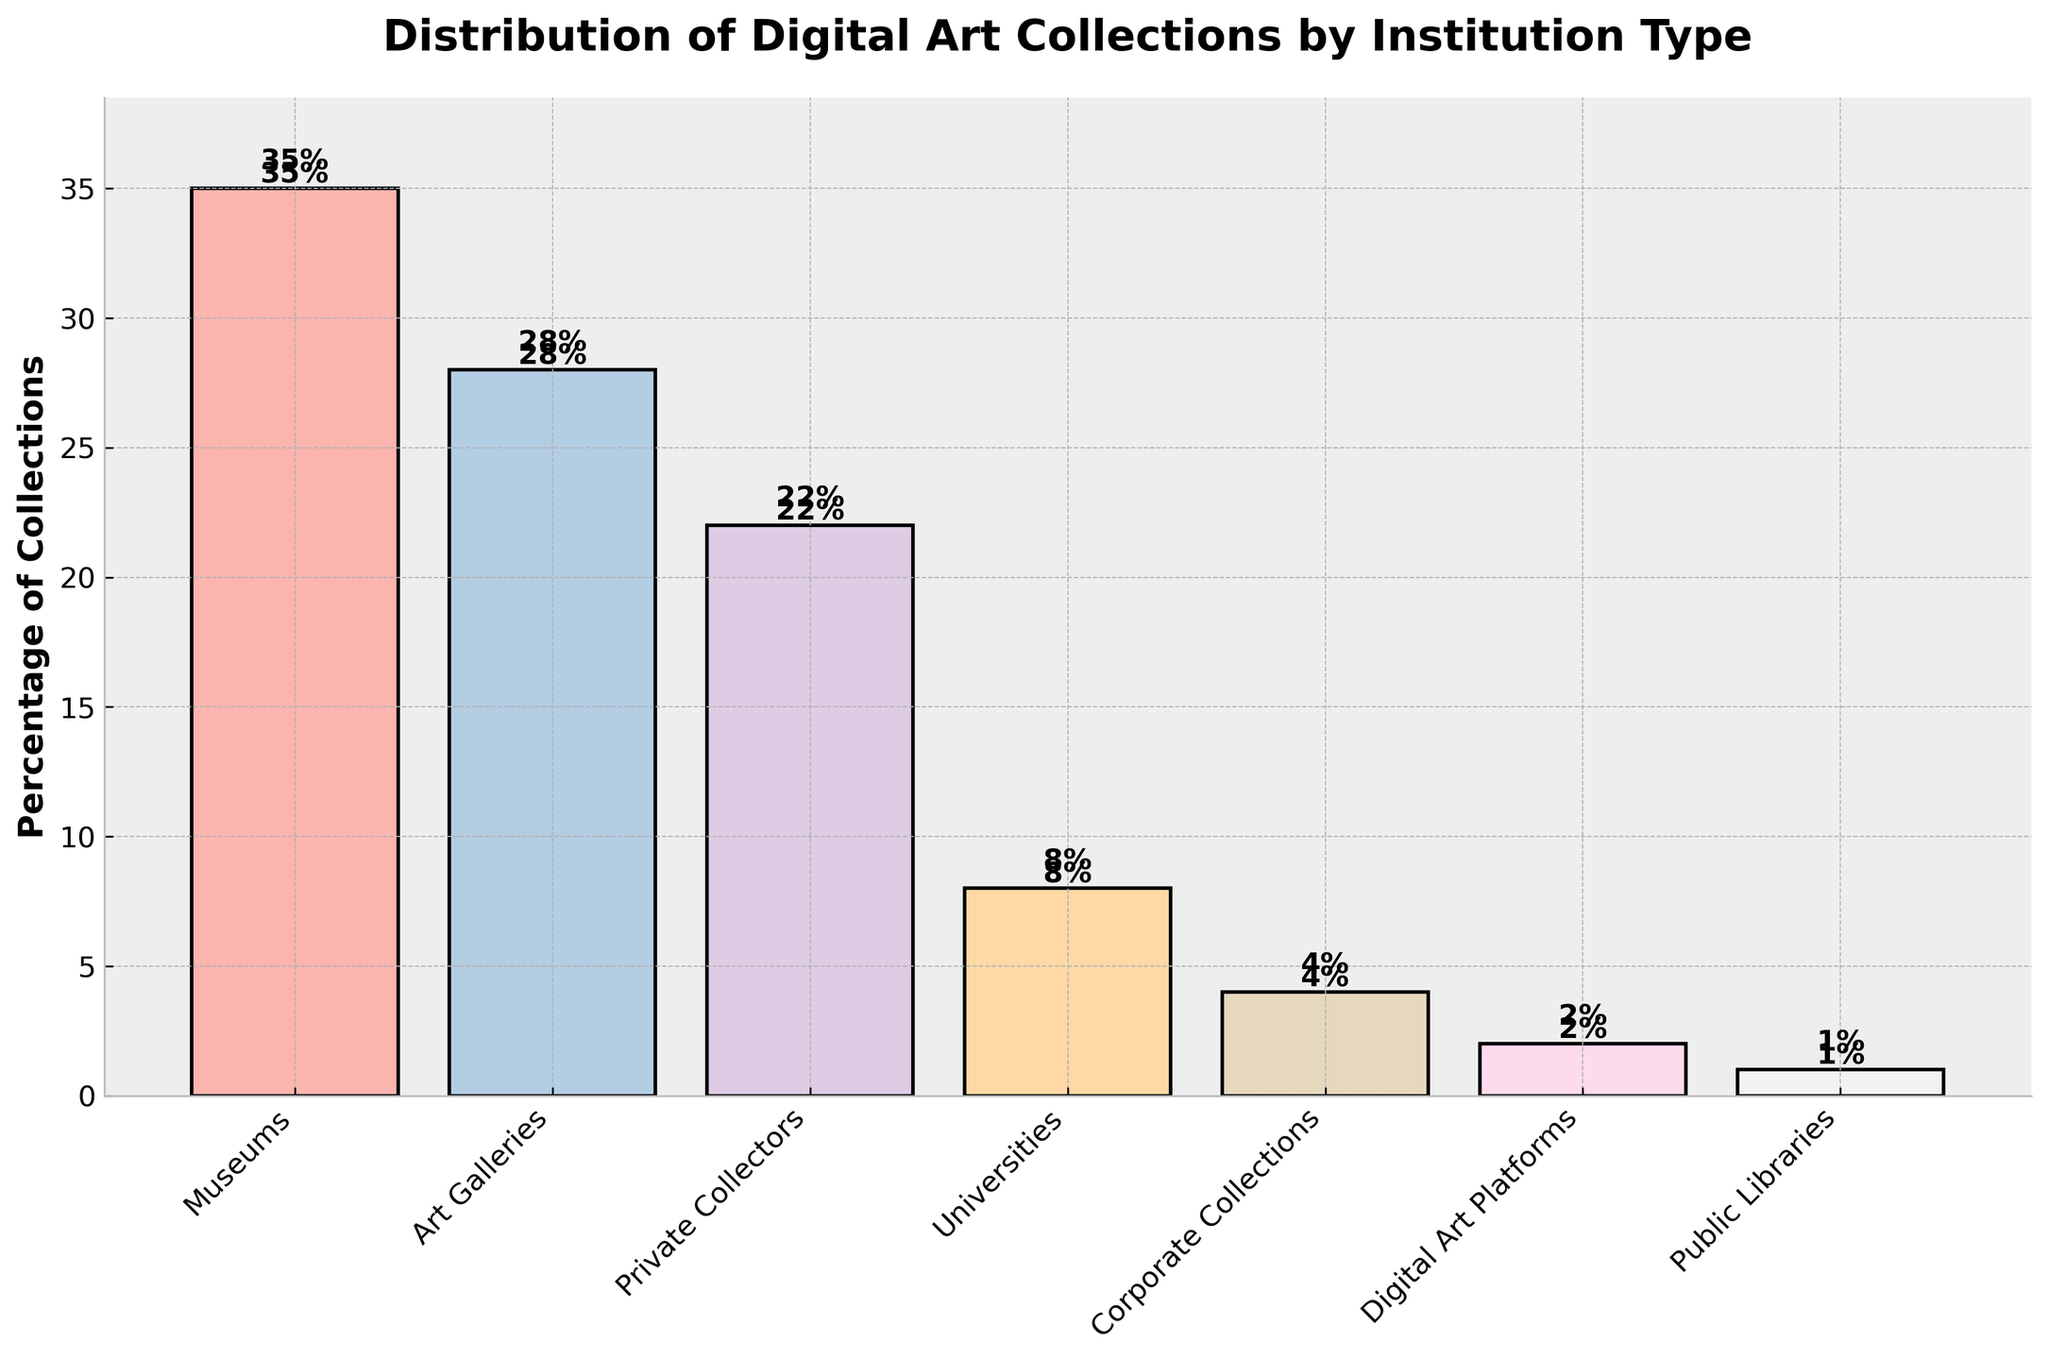Which institution type has the highest percentage of digital art collections? The bar corresponding to Museums is the highest among all, indicating it has the largest percentage.
Answer: Museums Which institution type has the lowest percentage of digital art collections? The bar corresponding to Public Libraries is the shortest, indicating it has the smallest percentage.
Answer: Public Libraries What is the percentage difference between Museums and Art Galleries? The percentage for Museums is 35% and for Art Galleries is 28%. The difference is calculated as 35% - 28%.
Answer: 7% What is the total percentage of digital art collections held by Universities, Corporate Collections, and Digital Art Platforms combined? Add the percentages for Universities (8%), Corporate Collections (4%), and Digital Art Platforms (2%). Total = 8% + 4% + 2%.
Answer: 14% Which has a higher percentage of digital art collections: Private Collectors or Art Galleries? The bar for Art Galleries (28%) is higher than the one for Private Collectors (22%).
Answer: Art Galleries How much more percentage of digital art collections do Museums hold compared to Private Collectors? The percentage for Museums is 35% and for Private Collectors is 22%. The difference is 35% - 22%.
Answer: 13% What is the combined percentage of digital art collections held by Museums and Art Galleries? Add the percentages of Museums (35%) and Art Galleries (28%). Total = 35% + 28%.
Answer: 63% What is the average percentage of digital art collections held by all institution types? Sum up all percentages (35% + 28% + 22% + 8% + 4% + 2% + 1%) and then divide by the number of institution types (7). Total = 100%, Average = 100% / 7.
Answer: 14.29% By how many percentage points do Universities exceed Corporate Collections in holding digital art collections? Universities have 8% while Corporate Collections have 4%. The difference is 8% - 4%.
Answer: 4% Compare the percentage of digital art collections held by Digital Art Platforms and Public Libraries. Which one holds more and by how much? The percentage for Digital Art Platforms is 2% and for Public Libraries is 1%. Digital Art Platforms hold more by 1%.
Answer: Digital Art Platforms, 1% 